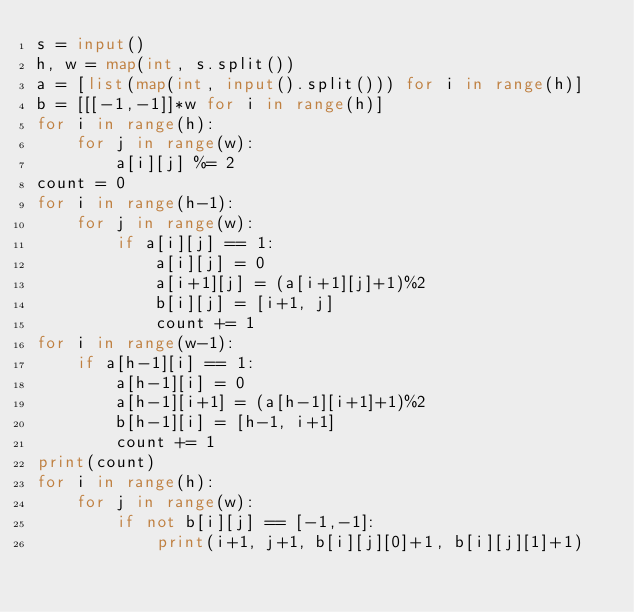Convert code to text. <code><loc_0><loc_0><loc_500><loc_500><_Python_>s = input()
h, w = map(int, s.split())
a = [list(map(int, input().split())) for i in range(h)]
b = [[[-1,-1]]*w for i in range(h)]
for i in range(h):
    for j in range(w):
        a[i][j] %= 2
count = 0
for i in range(h-1):
    for j in range(w):
        if a[i][j] == 1:
            a[i][j] = 0
            a[i+1][j] = (a[i+1][j]+1)%2
            b[i][j] = [i+1, j]
            count += 1
for i in range(w-1):
    if a[h-1][i] == 1:
        a[h-1][i] = 0
        a[h-1][i+1] = (a[h-1][i+1]+1)%2
        b[h-1][i] = [h-1, i+1]
        count += 1
print(count)
for i in range(h):
    for j in range(w):
        if not b[i][j] == [-1,-1]:
            print(i+1, j+1, b[i][j][0]+1, b[i][j][1]+1)
</code> 